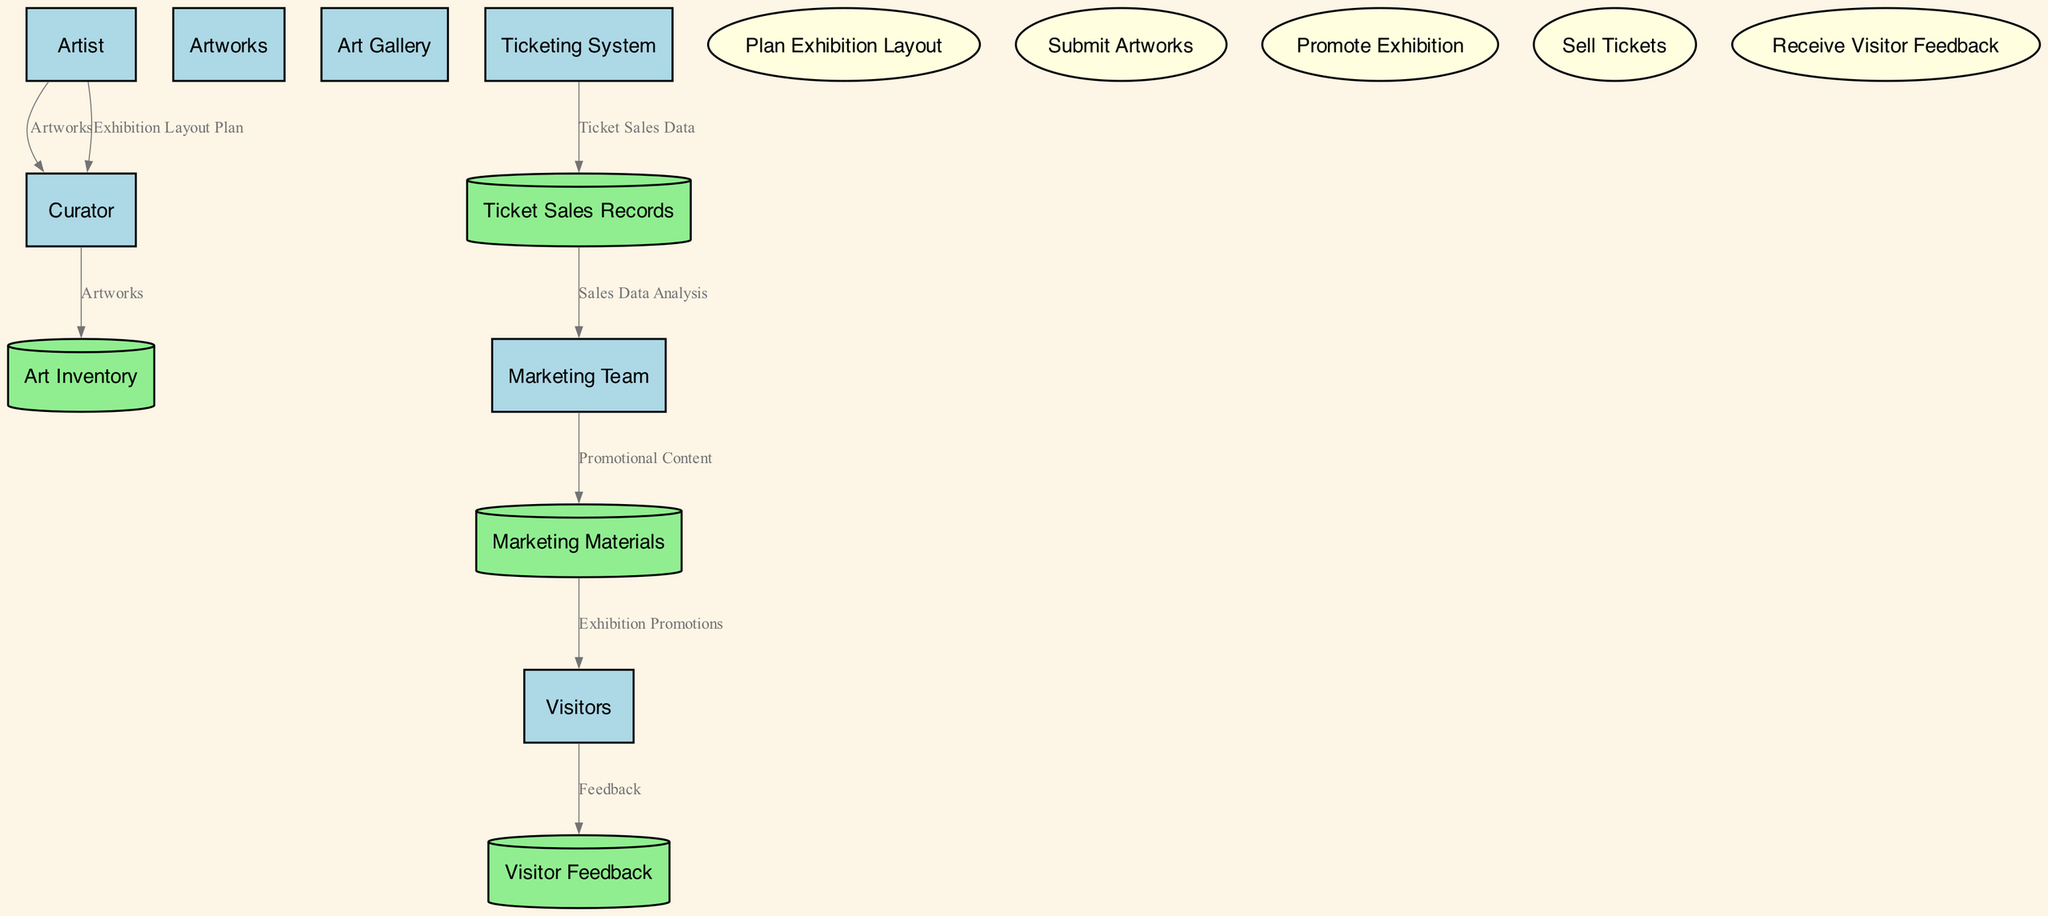What is the role of the Curator? The Curator is responsible for curating the art pieces and exhibition layout. This can be seen in the diagram where the Curator node is defined with this specific description.
Answer: Curator How many entities are involved in the diagram? There are six entities depicted in the diagram: Artist, Curator, Artworks, Art Gallery, Marketing Team, and Visitors. By counting the entity nodes, we find that there are a total of six.
Answer: Six What type of data flows from the Artist to the Curator? The data flows from the Artist to the Curator include Artworks and Exhibition Layout Plan. This information is represented by the directed edges leading from the Artist node to the Curator node, labeled accordingly.
Answer: Artworks and Exhibition Layout Plan Which entity collects Visitor Feedback? The entity that collects Visitor Feedback is the Gallery and Artist. The diagram indicates that feedback from Visitors is collected and directed toward the Visitor Feedback data store.
Answer: Gallery and Artist What does the Marketing Team create? The Marketing Team creates Marketing Materials. This is demonstrated in the diagram where there is a flow from the Marketing Team to the Marketing Materials data store, labeled with the data content as Promotional Content.
Answer: Marketing Materials Which process handles ticket sales? The process that handles ticket sales is the Sell Tickets process. In the diagram, this process is linked to the Ticketing System entity responsible for the handling of ticket sales and distributions.
Answer: Sell Tickets What data do Visitors provide? Visitors provide Feedback. The edges in the diagram illustrate the flow from Visitors to the Visitor Feedback data store, indicating the type of data being shared.
Answer: Feedback How does the Marketing Team utilize Ticket Sales Records? The Marketing Team utilizes Ticket Sales Records for Sales Data Analysis. The diagram shows a directed edge flowing from Ticket Sales Records to the Marketing Team, labeled with the specific data type involved.
Answer: Sales Data Analysis What is the purpose of the Art Inventory data store? The purpose of the Art Inventory data store is to keep a Database of all artworks submitted for the exhibition. This is indicated in the diagram, where the data store is linked to the Curator entity with a flow of Artworks.
Answer: Database of all artworks submitted for the exhibition 